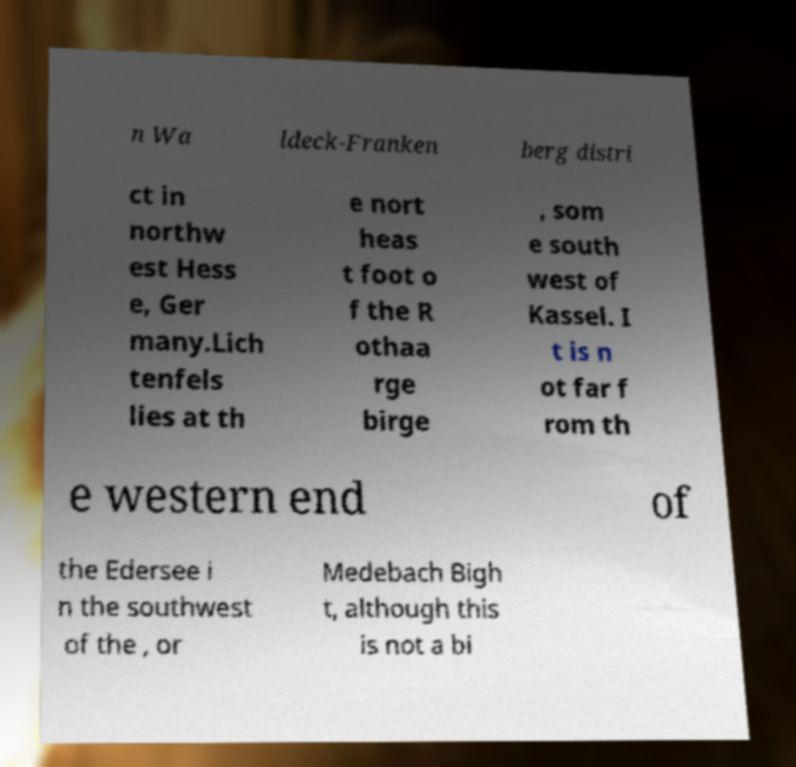Could you extract and type out the text from this image? n Wa ldeck-Franken berg distri ct in northw est Hess e, Ger many.Lich tenfels lies at th e nort heas t foot o f the R othaa rge birge , som e south west of Kassel. I t is n ot far f rom th e western end of the Edersee i n the southwest of the , or Medebach Bigh t, although this is not a bi 